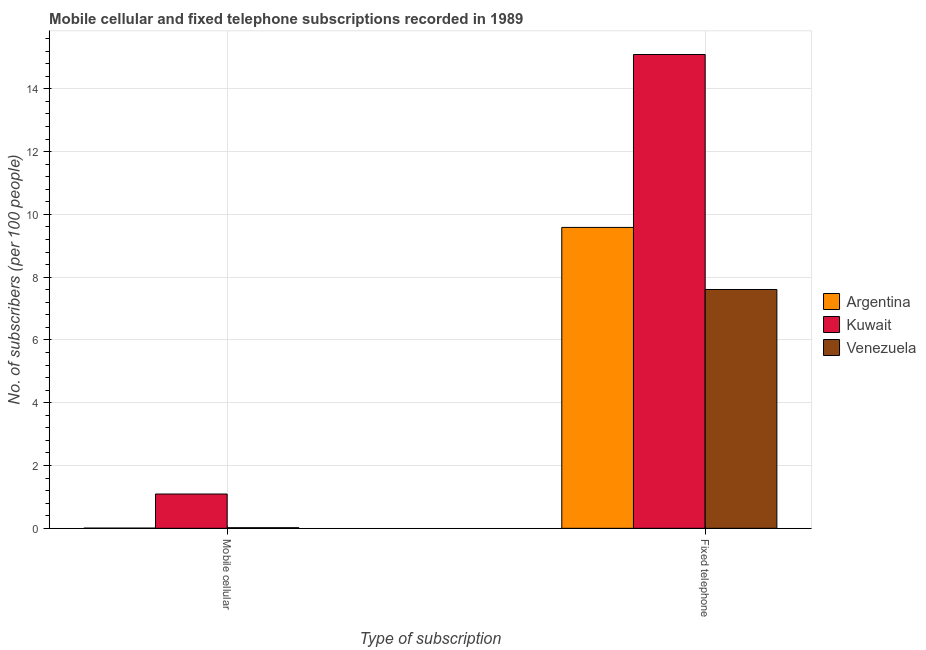How many different coloured bars are there?
Ensure brevity in your answer.  3. How many groups of bars are there?
Give a very brief answer. 2. How many bars are there on the 2nd tick from the left?
Offer a very short reply. 3. What is the label of the 2nd group of bars from the left?
Provide a short and direct response. Fixed telephone. What is the number of fixed telephone subscribers in Venezuela?
Your response must be concise. 7.61. Across all countries, what is the maximum number of fixed telephone subscribers?
Your response must be concise. 15.09. Across all countries, what is the minimum number of mobile cellular subscribers?
Offer a terse response. 0.01. In which country was the number of fixed telephone subscribers maximum?
Your answer should be very brief. Kuwait. In which country was the number of fixed telephone subscribers minimum?
Your response must be concise. Venezuela. What is the total number of mobile cellular subscribers in the graph?
Your answer should be very brief. 1.12. What is the difference between the number of fixed telephone subscribers in Argentina and that in Kuwait?
Keep it short and to the point. -5.51. What is the difference between the number of mobile cellular subscribers in Venezuela and the number of fixed telephone subscribers in Kuwait?
Keep it short and to the point. -15.08. What is the average number of fixed telephone subscribers per country?
Keep it short and to the point. 10.76. What is the difference between the number of fixed telephone subscribers and number of mobile cellular subscribers in Venezuela?
Provide a short and direct response. 7.59. In how many countries, is the number of mobile cellular subscribers greater than 9.6 ?
Your answer should be compact. 0. What is the ratio of the number of fixed telephone subscribers in Argentina to that in Venezuela?
Ensure brevity in your answer.  1.26. Is the number of fixed telephone subscribers in Kuwait less than that in Argentina?
Give a very brief answer. No. In how many countries, is the number of fixed telephone subscribers greater than the average number of fixed telephone subscribers taken over all countries?
Offer a very short reply. 1. What does the 2nd bar from the left in Fixed telephone represents?
Provide a short and direct response. Kuwait. What does the 2nd bar from the right in Fixed telephone represents?
Your answer should be compact. Kuwait. How many countries are there in the graph?
Your answer should be very brief. 3. How many legend labels are there?
Give a very brief answer. 3. How are the legend labels stacked?
Ensure brevity in your answer.  Vertical. What is the title of the graph?
Keep it short and to the point. Mobile cellular and fixed telephone subscriptions recorded in 1989. Does "Ghana" appear as one of the legend labels in the graph?
Give a very brief answer. No. What is the label or title of the X-axis?
Give a very brief answer. Type of subscription. What is the label or title of the Y-axis?
Your response must be concise. No. of subscribers (per 100 people). What is the No. of subscribers (per 100 people) in Argentina in Mobile cellular?
Ensure brevity in your answer.  0.01. What is the No. of subscribers (per 100 people) of Kuwait in Mobile cellular?
Your response must be concise. 1.09. What is the No. of subscribers (per 100 people) in Venezuela in Mobile cellular?
Keep it short and to the point. 0.02. What is the No. of subscribers (per 100 people) in Argentina in Fixed telephone?
Keep it short and to the point. 9.59. What is the No. of subscribers (per 100 people) in Kuwait in Fixed telephone?
Give a very brief answer. 15.09. What is the No. of subscribers (per 100 people) in Venezuela in Fixed telephone?
Keep it short and to the point. 7.61. Across all Type of subscription, what is the maximum No. of subscribers (per 100 people) of Argentina?
Your answer should be compact. 9.59. Across all Type of subscription, what is the maximum No. of subscribers (per 100 people) of Kuwait?
Keep it short and to the point. 15.09. Across all Type of subscription, what is the maximum No. of subscribers (per 100 people) in Venezuela?
Offer a terse response. 7.61. Across all Type of subscription, what is the minimum No. of subscribers (per 100 people) in Argentina?
Keep it short and to the point. 0.01. Across all Type of subscription, what is the minimum No. of subscribers (per 100 people) of Kuwait?
Provide a succinct answer. 1.09. Across all Type of subscription, what is the minimum No. of subscribers (per 100 people) of Venezuela?
Your answer should be compact. 0.02. What is the total No. of subscribers (per 100 people) of Argentina in the graph?
Your answer should be very brief. 9.59. What is the total No. of subscribers (per 100 people) in Kuwait in the graph?
Provide a short and direct response. 16.19. What is the total No. of subscribers (per 100 people) of Venezuela in the graph?
Ensure brevity in your answer.  7.63. What is the difference between the No. of subscribers (per 100 people) of Argentina in Mobile cellular and that in Fixed telephone?
Your answer should be compact. -9.58. What is the difference between the No. of subscribers (per 100 people) of Kuwait in Mobile cellular and that in Fixed telephone?
Keep it short and to the point. -14. What is the difference between the No. of subscribers (per 100 people) in Venezuela in Mobile cellular and that in Fixed telephone?
Offer a very short reply. -7.59. What is the difference between the No. of subscribers (per 100 people) of Argentina in Mobile cellular and the No. of subscribers (per 100 people) of Kuwait in Fixed telephone?
Your answer should be very brief. -15.09. What is the difference between the No. of subscribers (per 100 people) of Argentina in Mobile cellular and the No. of subscribers (per 100 people) of Venezuela in Fixed telephone?
Offer a very short reply. -7.6. What is the difference between the No. of subscribers (per 100 people) in Kuwait in Mobile cellular and the No. of subscribers (per 100 people) in Venezuela in Fixed telephone?
Keep it short and to the point. -6.52. What is the average No. of subscribers (per 100 people) of Argentina per Type of subscription?
Give a very brief answer. 4.8. What is the average No. of subscribers (per 100 people) of Kuwait per Type of subscription?
Your answer should be compact. 8.09. What is the average No. of subscribers (per 100 people) in Venezuela per Type of subscription?
Provide a succinct answer. 3.81. What is the difference between the No. of subscribers (per 100 people) of Argentina and No. of subscribers (per 100 people) of Kuwait in Mobile cellular?
Your response must be concise. -1.09. What is the difference between the No. of subscribers (per 100 people) of Argentina and No. of subscribers (per 100 people) of Venezuela in Mobile cellular?
Give a very brief answer. -0.01. What is the difference between the No. of subscribers (per 100 people) of Kuwait and No. of subscribers (per 100 people) of Venezuela in Mobile cellular?
Offer a terse response. 1.07. What is the difference between the No. of subscribers (per 100 people) of Argentina and No. of subscribers (per 100 people) of Kuwait in Fixed telephone?
Keep it short and to the point. -5.51. What is the difference between the No. of subscribers (per 100 people) of Argentina and No. of subscribers (per 100 people) of Venezuela in Fixed telephone?
Your response must be concise. 1.98. What is the difference between the No. of subscribers (per 100 people) of Kuwait and No. of subscribers (per 100 people) of Venezuela in Fixed telephone?
Your answer should be compact. 7.49. What is the ratio of the No. of subscribers (per 100 people) of Argentina in Mobile cellular to that in Fixed telephone?
Keep it short and to the point. 0. What is the ratio of the No. of subscribers (per 100 people) of Kuwait in Mobile cellular to that in Fixed telephone?
Your answer should be compact. 0.07. What is the ratio of the No. of subscribers (per 100 people) of Venezuela in Mobile cellular to that in Fixed telephone?
Your answer should be very brief. 0. What is the difference between the highest and the second highest No. of subscribers (per 100 people) in Argentina?
Give a very brief answer. 9.58. What is the difference between the highest and the second highest No. of subscribers (per 100 people) of Kuwait?
Your answer should be compact. 14. What is the difference between the highest and the second highest No. of subscribers (per 100 people) in Venezuela?
Offer a terse response. 7.59. What is the difference between the highest and the lowest No. of subscribers (per 100 people) of Argentina?
Give a very brief answer. 9.58. What is the difference between the highest and the lowest No. of subscribers (per 100 people) in Kuwait?
Ensure brevity in your answer.  14. What is the difference between the highest and the lowest No. of subscribers (per 100 people) in Venezuela?
Ensure brevity in your answer.  7.59. 